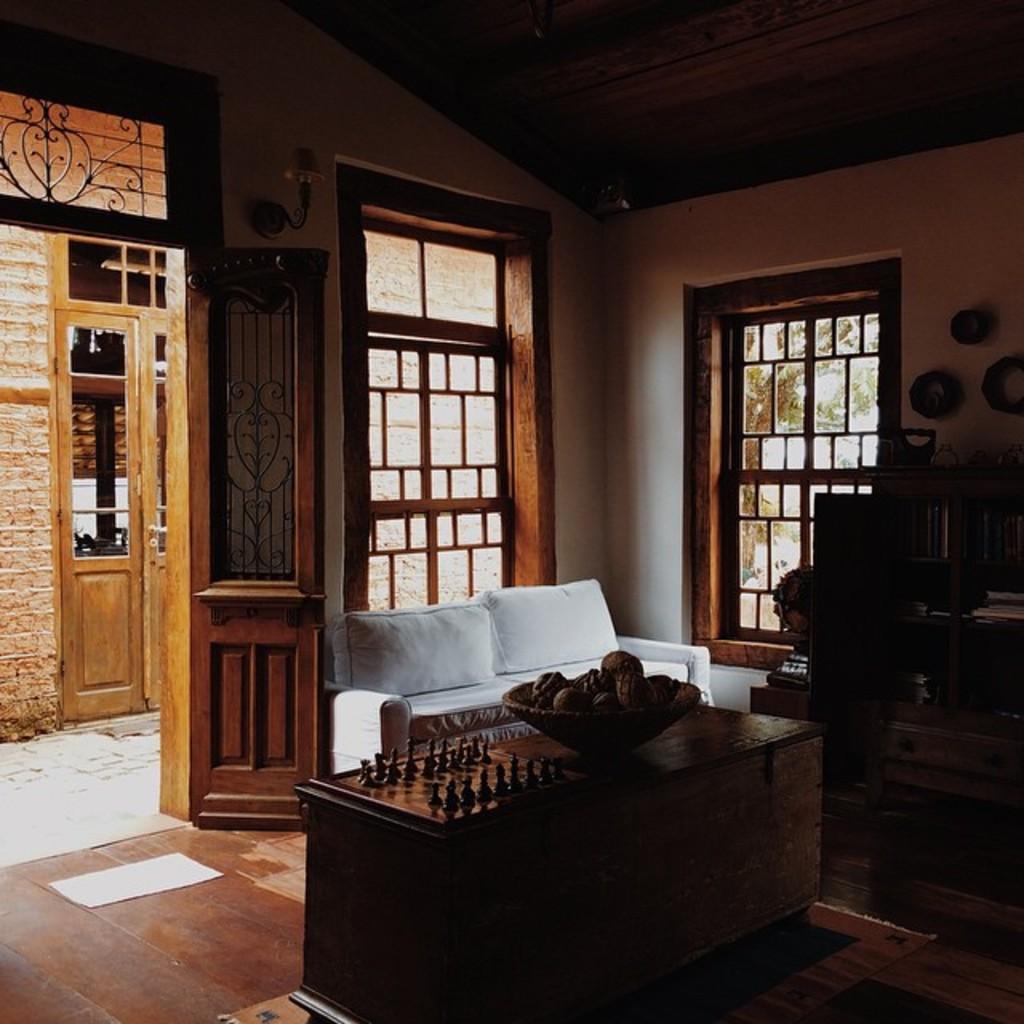How would you summarize this image in a sentence or two? In a room there is a sofa with pillows and table with bowl of fruits on it. Behind the bowl there is a chess board and opposite to table there is a book shelf with books in it. 